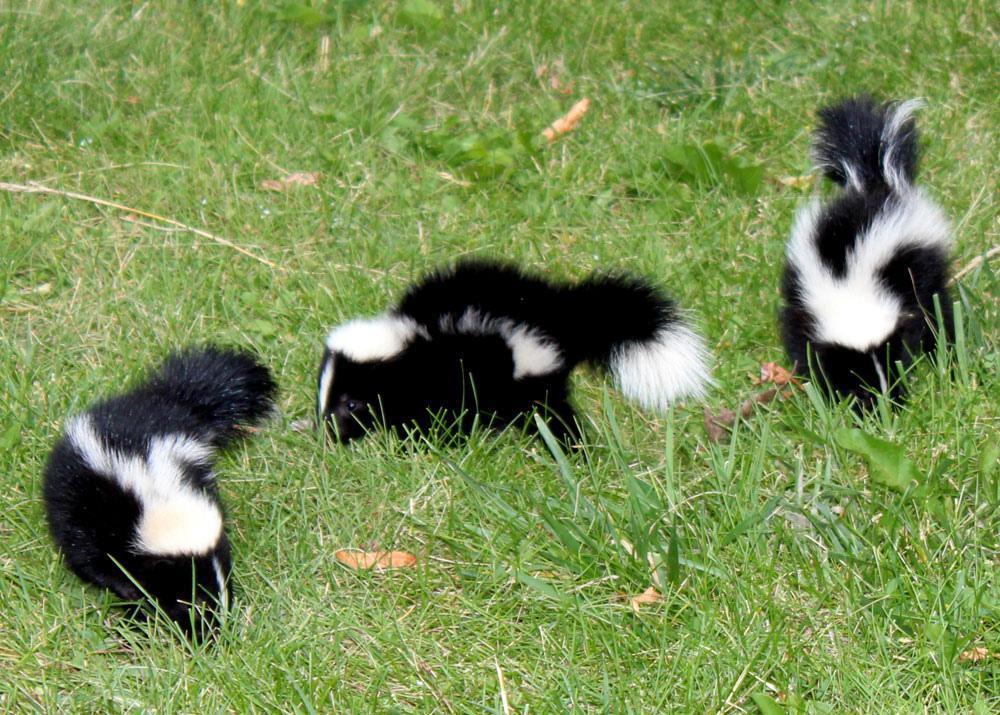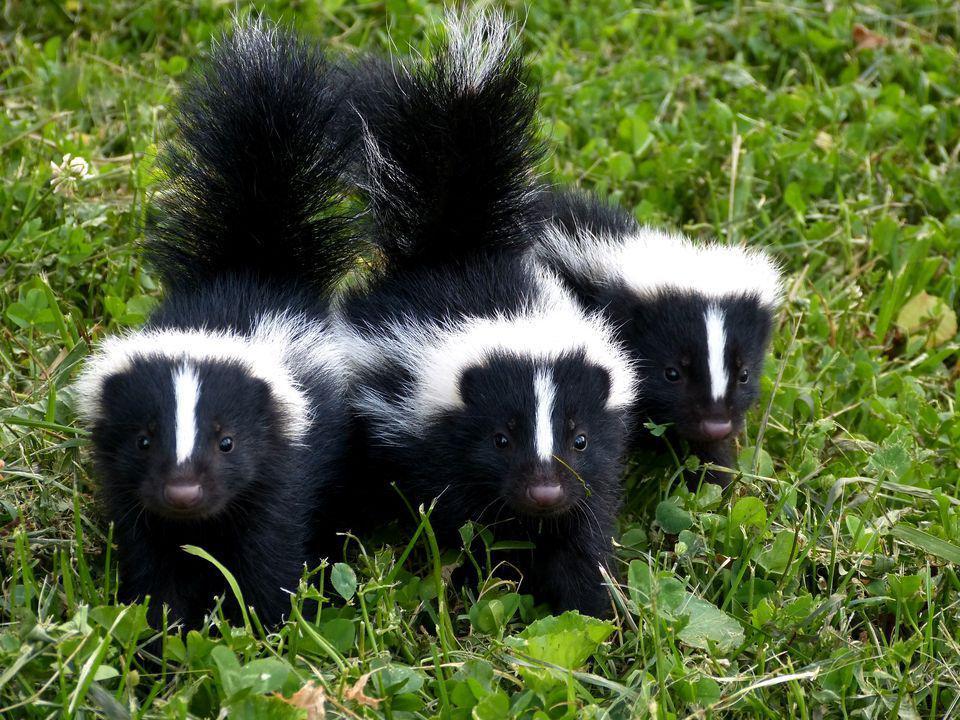The first image is the image on the left, the second image is the image on the right. Given the left and right images, does the statement "There are six skunks pictured." hold true? Answer yes or no. Yes. 